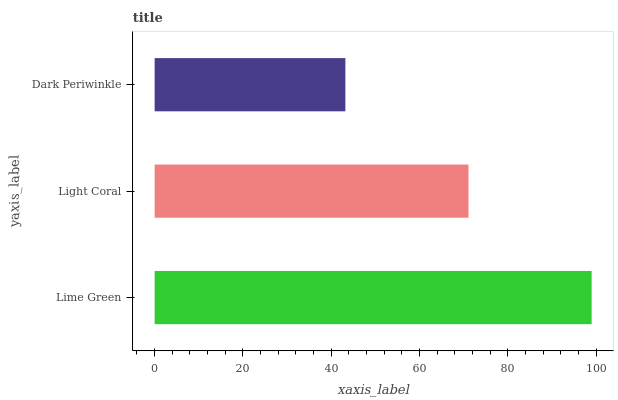Is Dark Periwinkle the minimum?
Answer yes or no. Yes. Is Lime Green the maximum?
Answer yes or no. Yes. Is Light Coral the minimum?
Answer yes or no. No. Is Light Coral the maximum?
Answer yes or no. No. Is Lime Green greater than Light Coral?
Answer yes or no. Yes. Is Light Coral less than Lime Green?
Answer yes or no. Yes. Is Light Coral greater than Lime Green?
Answer yes or no. No. Is Lime Green less than Light Coral?
Answer yes or no. No. Is Light Coral the high median?
Answer yes or no. Yes. Is Light Coral the low median?
Answer yes or no. Yes. Is Dark Periwinkle the high median?
Answer yes or no. No. Is Dark Periwinkle the low median?
Answer yes or no. No. 